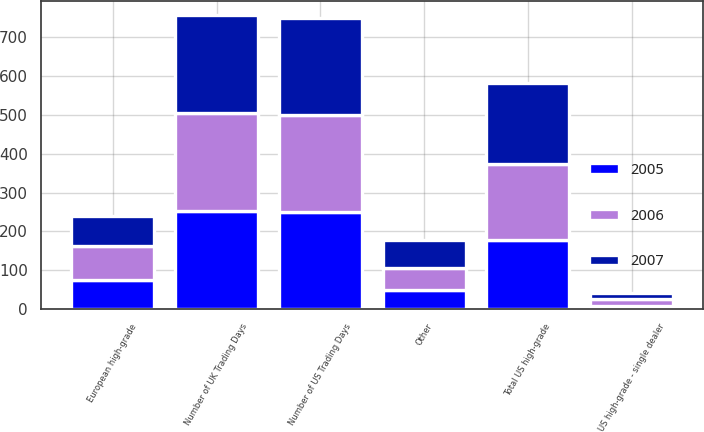<chart> <loc_0><loc_0><loc_500><loc_500><stacked_bar_chart><ecel><fcel>US high-grade - single dealer<fcel>Total US high-grade<fcel>European high-grade<fcel>Other<fcel>Number of US Trading Days<fcel>Number of UK Trading Days<nl><fcel>2007<fcel>15.1<fcel>209.2<fcel>77.4<fcel>73.3<fcel>250<fcel>253<nl><fcel>2006<fcel>19<fcel>195.4<fcel>87.6<fcel>56.6<fcel>249<fcel>251<nl><fcel>2005<fcel>7.5<fcel>177.6<fcel>73.4<fcel>48.2<fcel>250<fcel>253<nl></chart> 